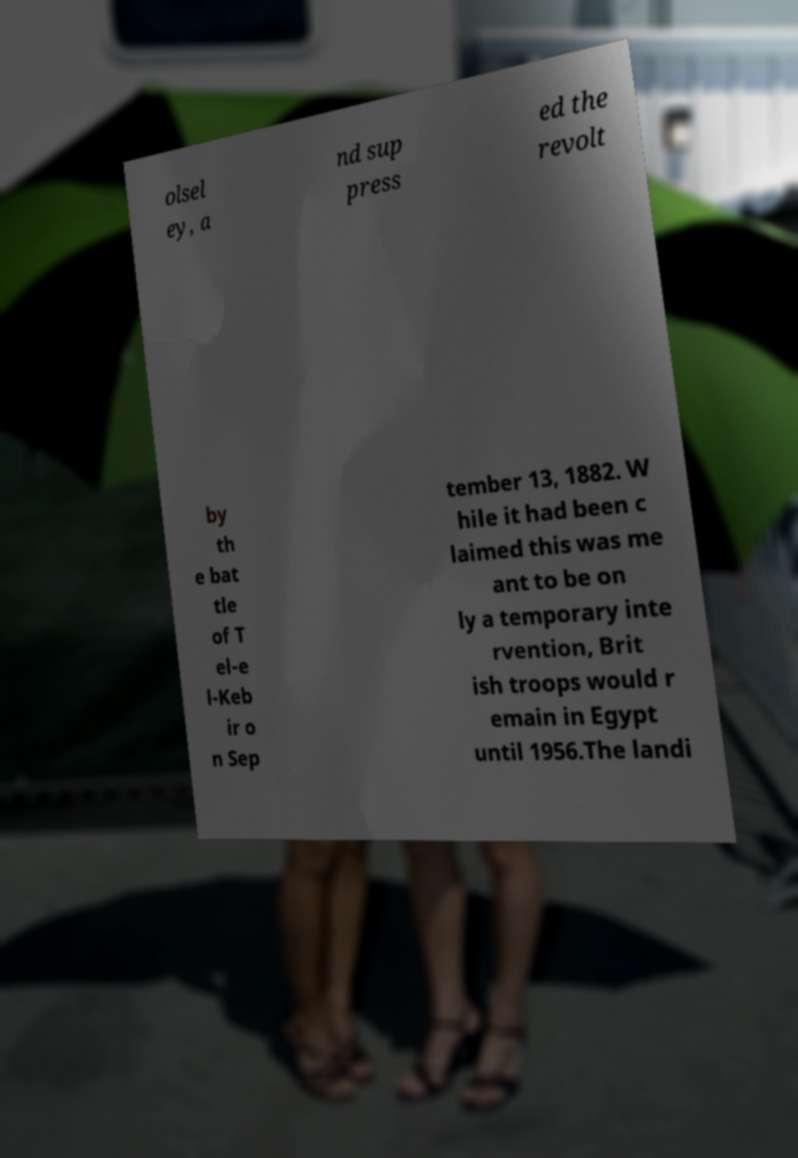Could you extract and type out the text from this image? olsel ey, a nd sup press ed the revolt by th e bat tle of T el-e l-Keb ir o n Sep tember 13, 1882. W hile it had been c laimed this was me ant to be on ly a temporary inte rvention, Brit ish troops would r emain in Egypt until 1956.The landi 